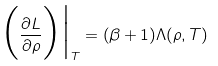<formula> <loc_0><loc_0><loc_500><loc_500>\Big ( \frac { \partial L } { \partial \rho } \Big ) \Big | _ { T } = ( \beta + 1 ) \Lambda ( \rho , T )</formula> 